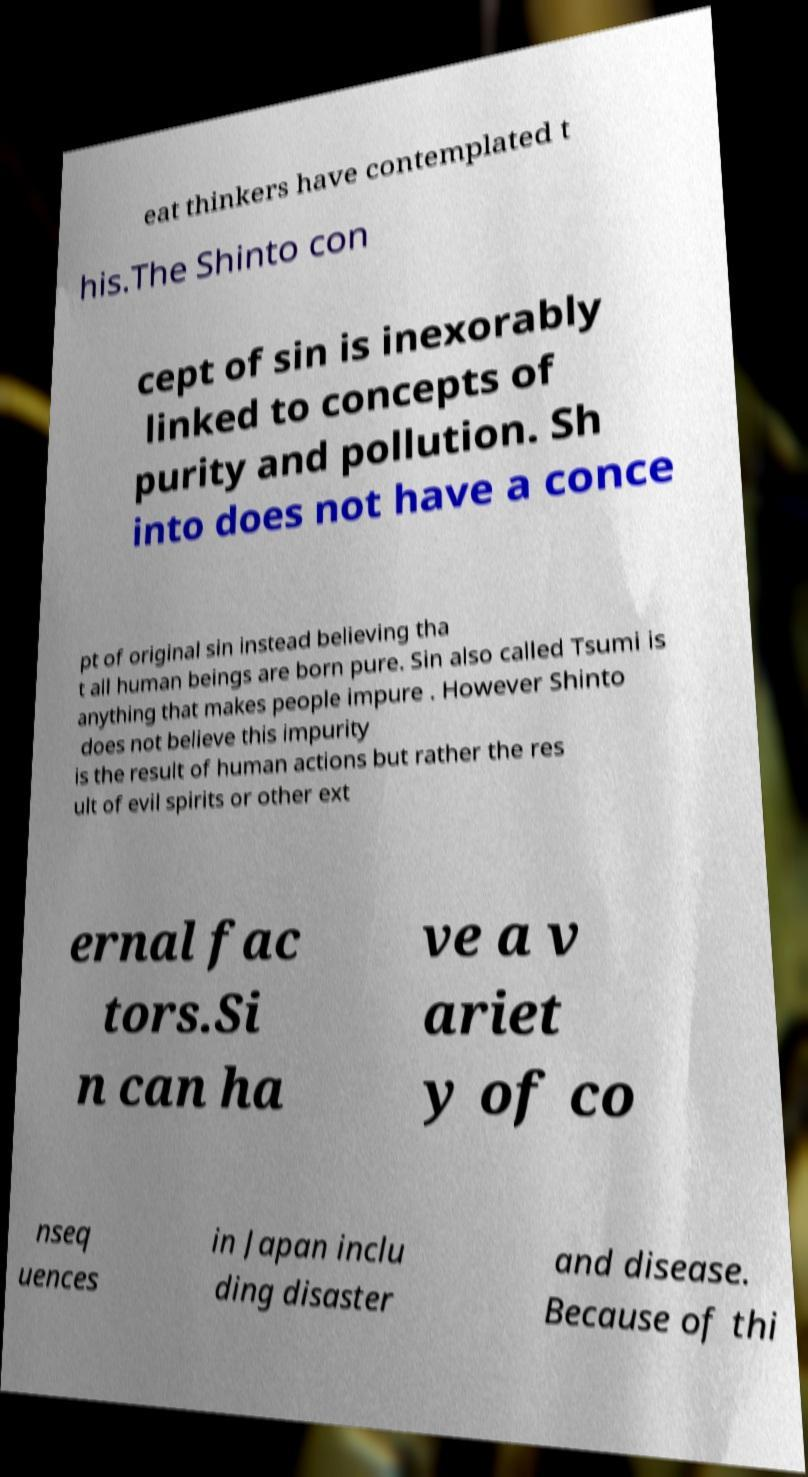Can you accurately transcribe the text from the provided image for me? eat thinkers have contemplated t his.The Shinto con cept of sin is inexorably linked to concepts of purity and pollution. Sh into does not have a conce pt of original sin instead believing tha t all human beings are born pure. Sin also called Tsumi is anything that makes people impure . However Shinto does not believe this impurity is the result of human actions but rather the res ult of evil spirits or other ext ernal fac tors.Si n can ha ve a v ariet y of co nseq uences in Japan inclu ding disaster and disease. Because of thi 